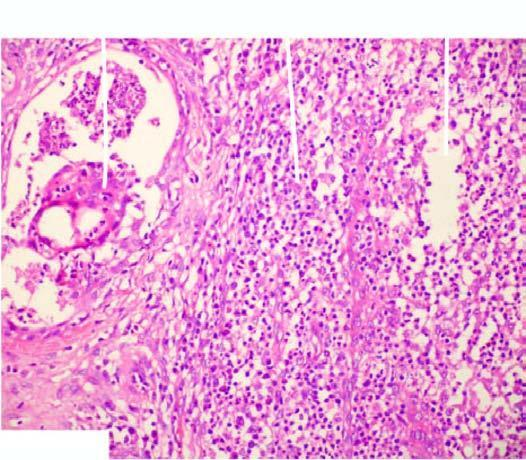what is there of a lipogranuloma having central pool of fat and surrounded by mixed inflammatory cells and foreign body type multinucleated giant cells?
Answer the question using a single word or phrase. Presence of a lipogranuloma 